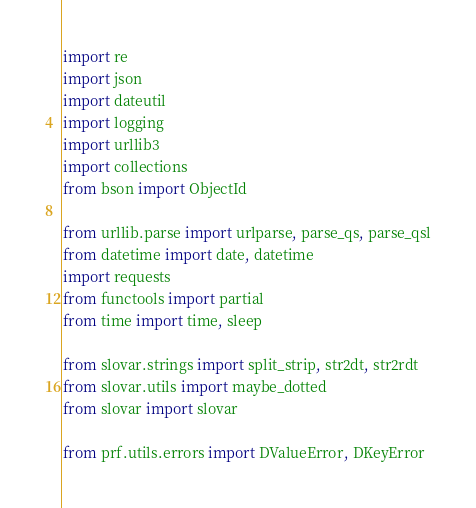Convert code to text. <code><loc_0><loc_0><loc_500><loc_500><_Python_>import re
import json
import dateutil
import logging
import urllib3
import collections
from bson import ObjectId

from urllib.parse import urlparse, parse_qs, parse_qsl
from datetime import date, datetime
import requests
from functools import partial
from time import time, sleep

from slovar.strings import split_strip, str2dt, str2rdt
from slovar.utils import maybe_dotted
from slovar import slovar

from prf.utils.errors import DValueError, DKeyError
</code> 